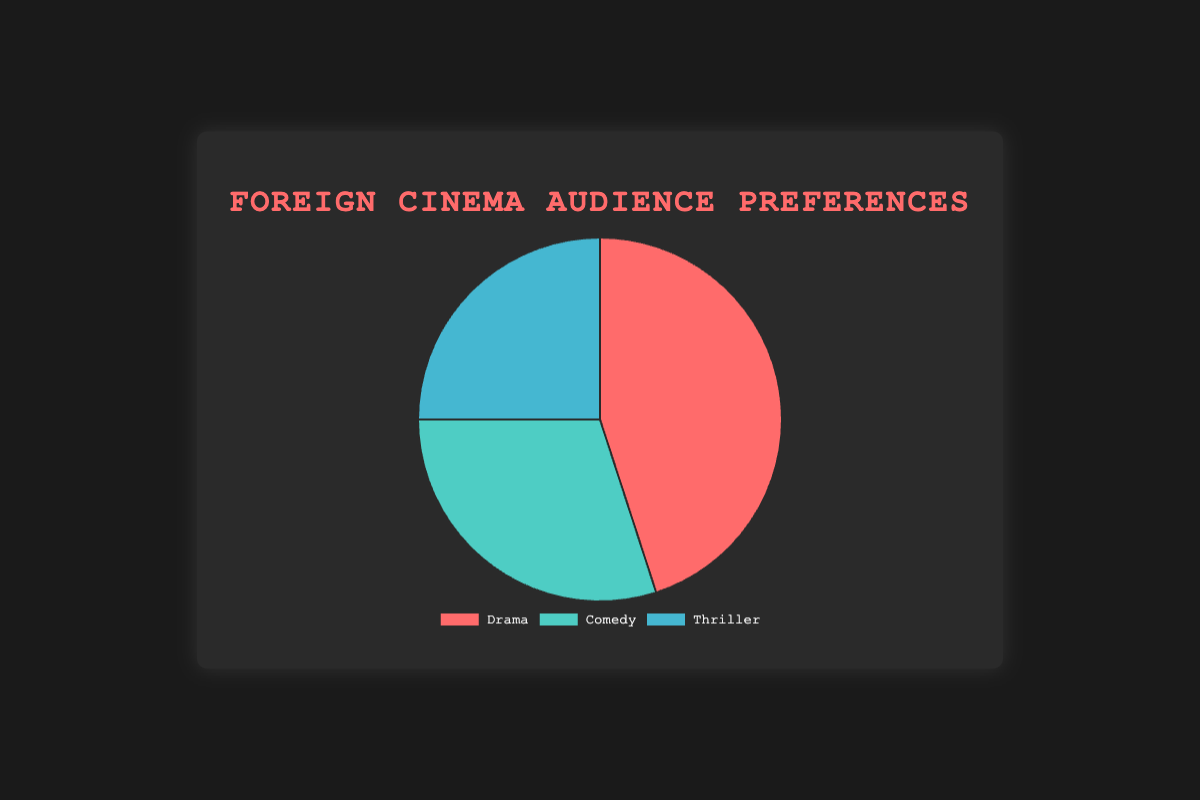What percentage of the audience watched Comedy cinema? Look at the chart and find the slice labeled "Comedy." The corresponding value is 30%.
Answer: 30% Which genre has the highest percentage of viewers? Identify the largest slice in the pie chart. The slice labeled "Drama" is the largest with 45%.
Answer: Drama What is the combined percentage of viewers for Comedy and Thriller? Add the percentages for Comedy (30%) and Thriller (25%). The sum is 55%.
Answer: 55% By how much does the Drama percentage exceed the Thriller percentage? Subtract the percentage of Thriller viewers (25%) from the percentage of Drama viewers (45%). The difference is 20%.
Answer: 20% Which genre has fewer viewers: Comedy or Thriller? Compare the segments for Comedy (30%) and Thriller (25%). Thriller has fewer viewers with 25%.
Answer: Thriller What is the difference between the most-watched and least-watched genres? Identify the most-watched (Drama, 45%) and the least-watched (Thriller, 25%) genres, then subtract the percentages: 45% - 25% = 20%.
Answer: 20% What is the total percentage of viewers for all genres combined? Add the percentages for Drama (45%), Comedy (30%), and Thriller (25%). The total is 100%.
Answer: 100% Is the percentage of Drama viewers greater than the sum of Comedy and Thriller viewers? Sum the percentages of Comedy (30%) and Thriller (25%) to get 55%, then compare it with Drama (45%). 45% is less than 55%.
Answer: No What color represents the Thriller genre? Observe the color coding in the pie chart. The slice labeled "Thriller" is light blue.
Answer: Light blue What is the average percentage of viewers across all genres? Sum the percentages for Drama (45%), Comedy (30%), and Thriller (25%) to get 100%, then divide by the number of genres (3). The average is 100/3 ≈ 33.33%.
Answer: 33.33% 